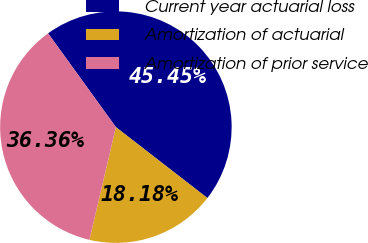<chart> <loc_0><loc_0><loc_500><loc_500><pie_chart><fcel>Current year actuarial loss<fcel>Amortization of actuarial<fcel>Amortization of prior service<nl><fcel>45.45%<fcel>18.18%<fcel>36.36%<nl></chart> 